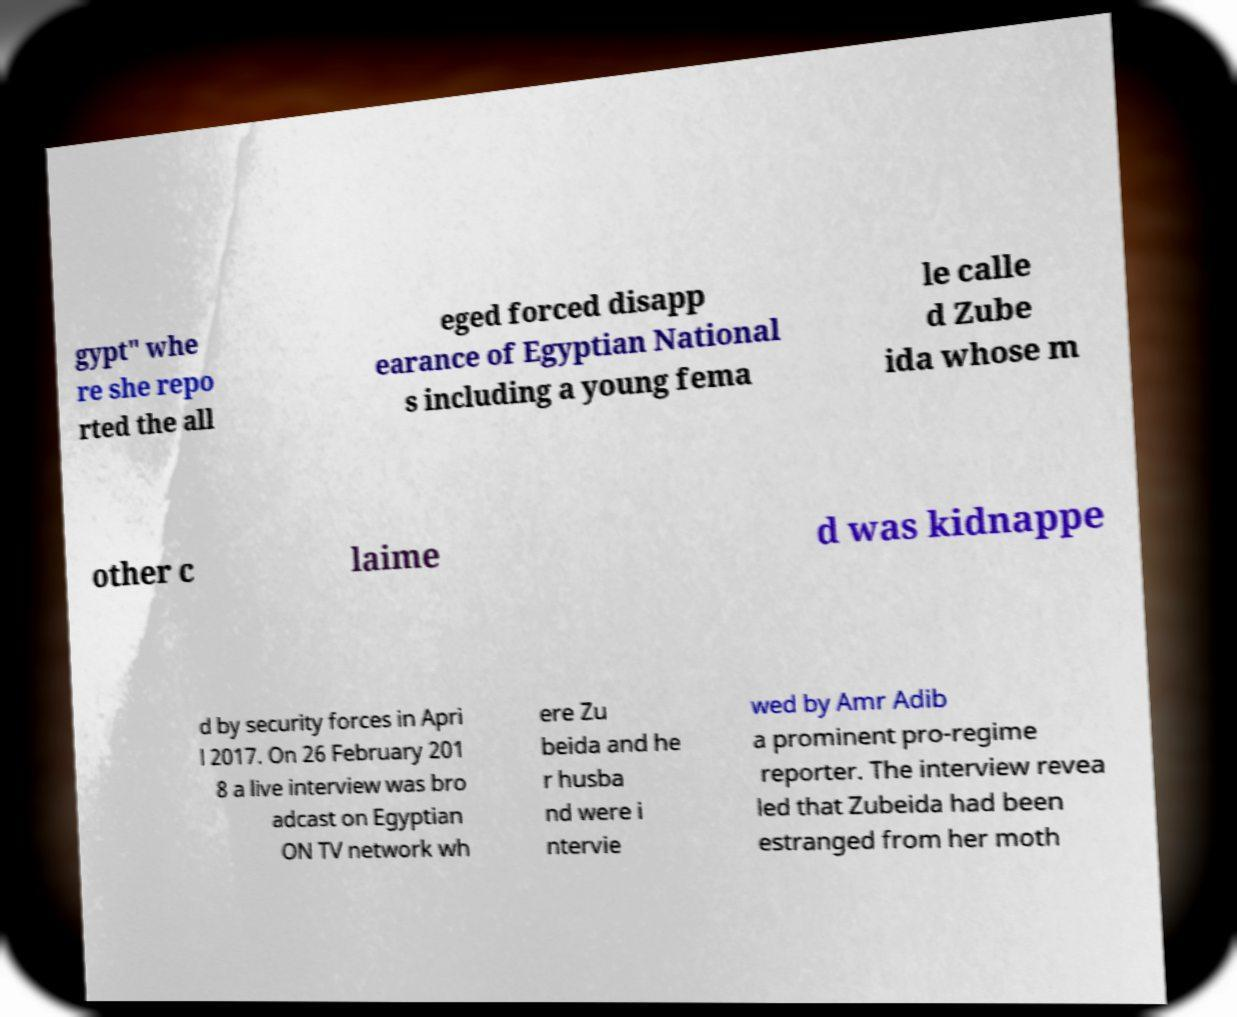Can you read and provide the text displayed in the image?This photo seems to have some interesting text. Can you extract and type it out for me? gypt" whe re she repo rted the all eged forced disapp earance of Egyptian National s including a young fema le calle d Zube ida whose m other c laime d was kidnappe d by security forces in Apri l 2017. On 26 February 201 8 a live interview was bro adcast on Egyptian ON TV network wh ere Zu beida and he r husba nd were i ntervie wed by Amr Adib a prominent pro-regime reporter. The interview revea led that Zubeida had been estranged from her moth 